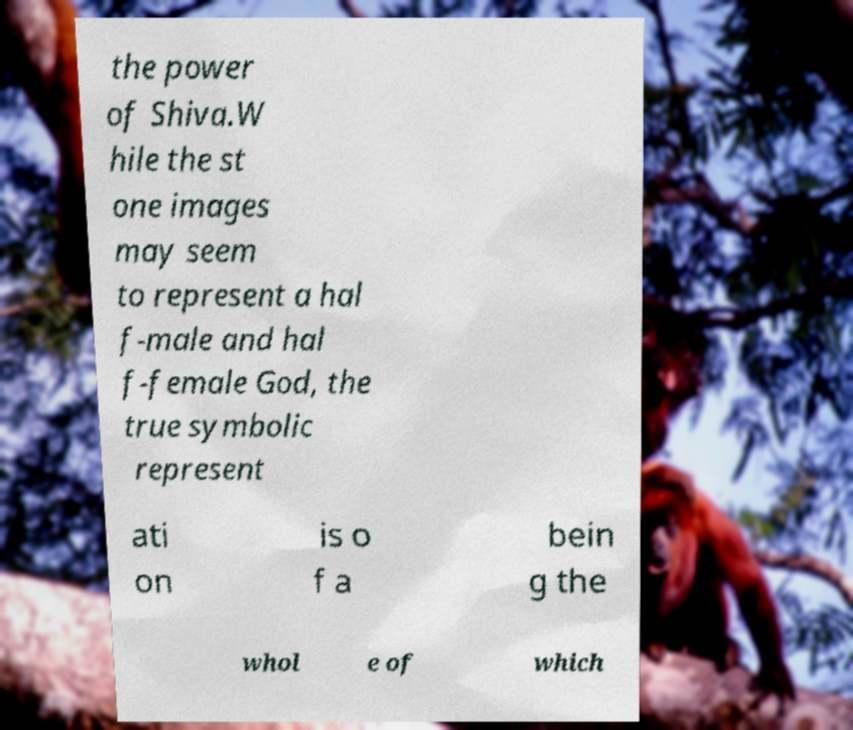There's text embedded in this image that I need extracted. Can you transcribe it verbatim? the power of Shiva.W hile the st one images may seem to represent a hal f-male and hal f-female God, the true symbolic represent ati on is o f a bein g the whol e of which 